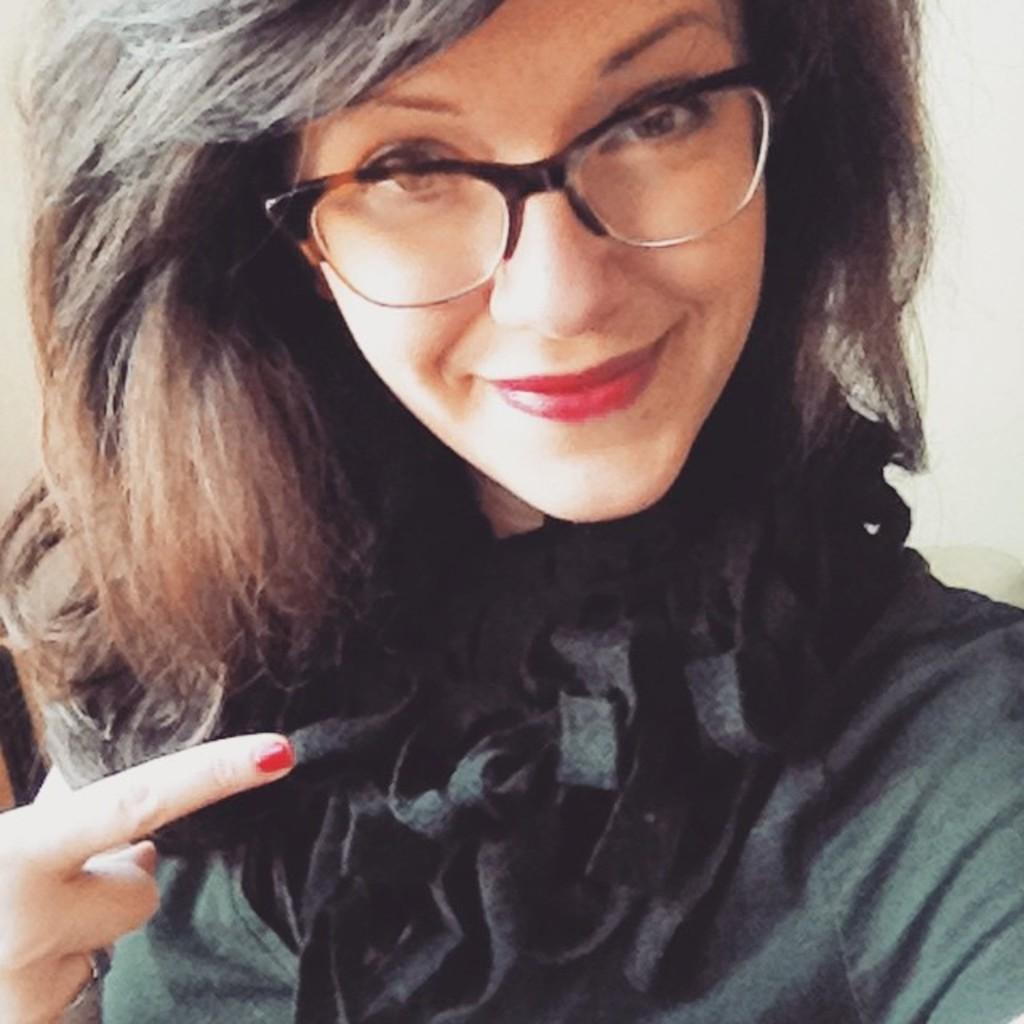Can you describe this image briefly? In this image we can see a woman. 